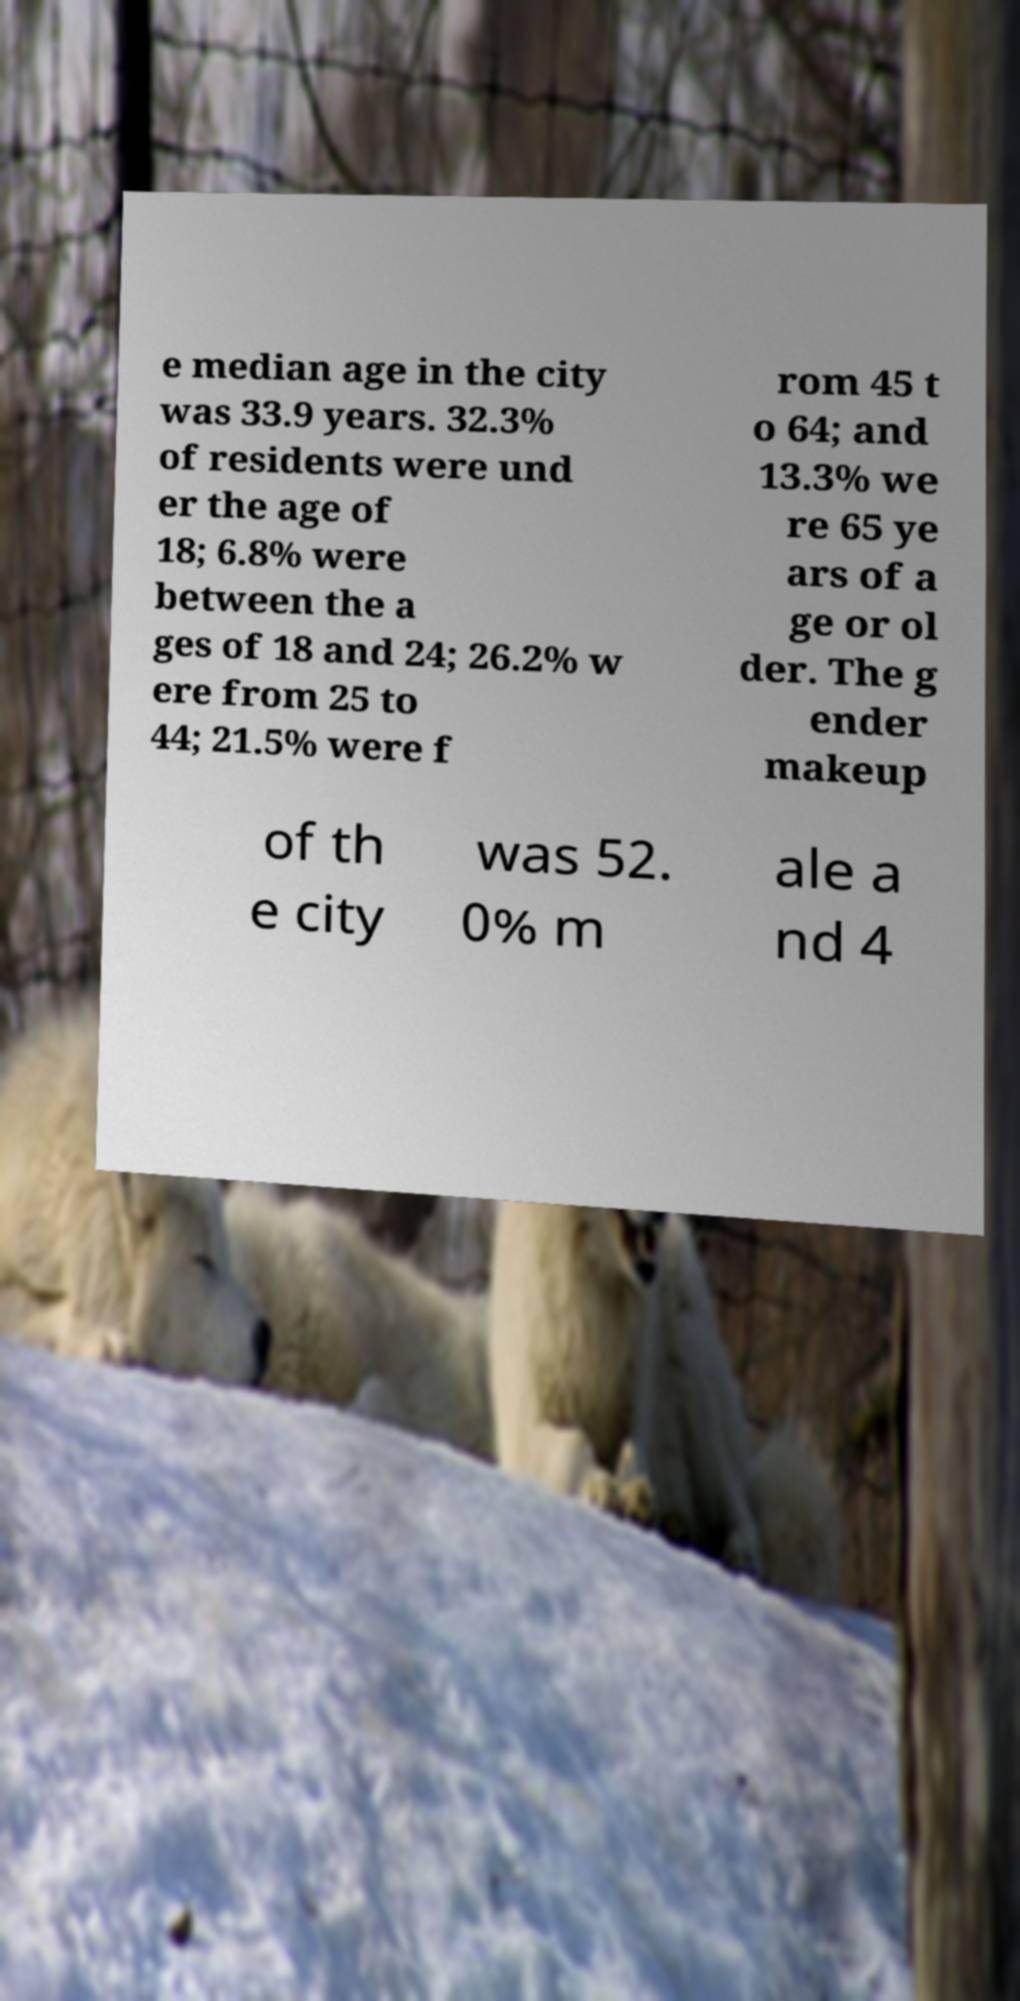Can you accurately transcribe the text from the provided image for me? e median age in the city was 33.9 years. 32.3% of residents were und er the age of 18; 6.8% were between the a ges of 18 and 24; 26.2% w ere from 25 to 44; 21.5% were f rom 45 t o 64; and 13.3% we re 65 ye ars of a ge or ol der. The g ender makeup of th e city was 52. 0% m ale a nd 4 